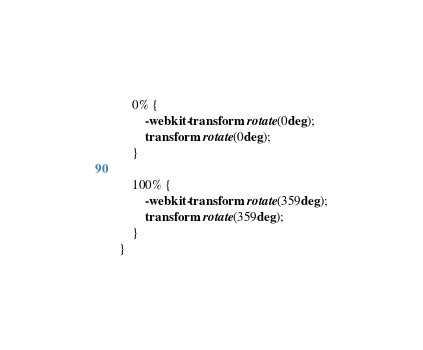<code> <loc_0><loc_0><loc_500><loc_500><_CSS_>    0% {
        -webkit-transform: rotate(0deg);
        transform: rotate(0deg);
    }

    100% {
        -webkit-transform: rotate(359deg);
        transform: rotate(359deg);
    }
}
</code> 